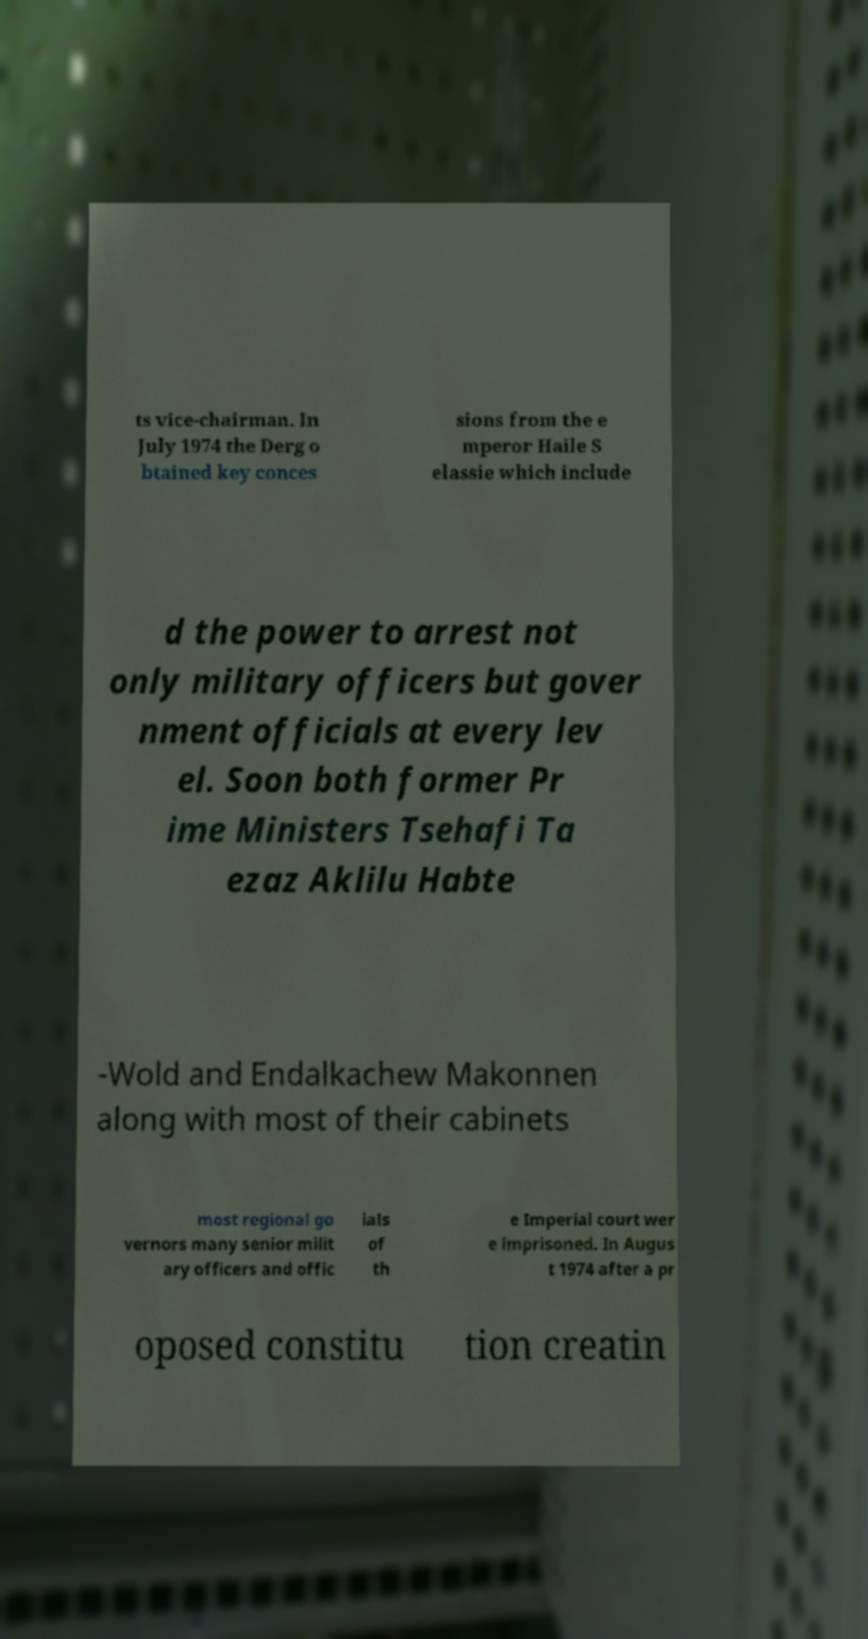Can you read and provide the text displayed in the image?This photo seems to have some interesting text. Can you extract and type it out for me? ts vice-chairman. In July 1974 the Derg o btained key conces sions from the e mperor Haile S elassie which include d the power to arrest not only military officers but gover nment officials at every lev el. Soon both former Pr ime Ministers Tsehafi Ta ezaz Aklilu Habte -Wold and Endalkachew Makonnen along with most of their cabinets most regional go vernors many senior milit ary officers and offic ials of th e Imperial court wer e imprisoned. In Augus t 1974 after a pr oposed constitu tion creatin 